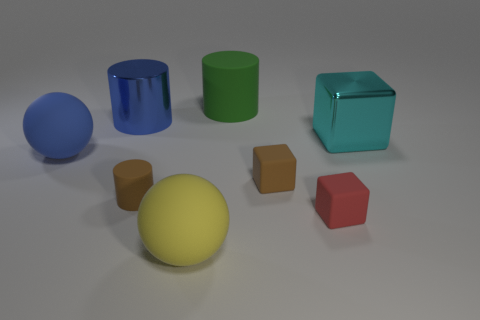There is a object that is the same color as the big shiny cylinder; what is it made of?
Make the answer very short. Rubber. How many small things are either gray matte cylinders or blue things?
Provide a short and direct response. 0. What is the shape of the large blue thing in front of the cyan shiny cube?
Give a very brief answer. Sphere. Is there a matte sphere that has the same color as the shiny cylinder?
Offer a very short reply. Yes. Does the blue object behind the cyan cube have the same size as the matte ball that is behind the yellow matte object?
Your response must be concise. Yes. Are there more big rubber cylinders on the right side of the green matte cylinder than blue metallic cylinders that are on the right side of the brown block?
Ensure brevity in your answer.  No. Is there a large cyan block that has the same material as the large blue cylinder?
Offer a very short reply. Yes. The large object that is both behind the big cyan thing and in front of the large green matte object is made of what material?
Your answer should be very brief. Metal. The large metallic block has what color?
Your answer should be very brief. Cyan. How many tiny brown rubber objects are the same shape as the yellow rubber thing?
Keep it short and to the point. 0. 